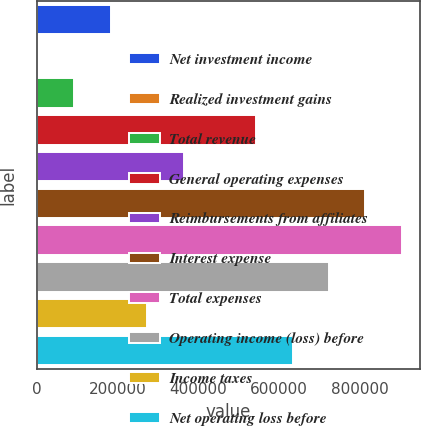<chart> <loc_0><loc_0><loc_500><loc_500><bar_chart><fcel>Net investment income<fcel>Realized investment gains<fcel>Total revenue<fcel>General operating expenses<fcel>Reimbursements from affiliates<fcel>Interest expense<fcel>Total expenses<fcel>Operating income (loss) before<fcel>Income taxes<fcel>Net operating loss before<nl><fcel>183764<fcel>3534<fcel>93648.9<fcel>544223<fcel>363994<fcel>814568<fcel>904683<fcel>724453<fcel>273879<fcel>634338<nl></chart> 